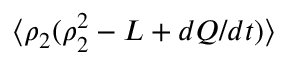Convert formula to latex. <formula><loc_0><loc_0><loc_500><loc_500>\langle \rho _ { 2 } ( \rho _ { 2 } ^ { 2 } - L + d Q / d t ) \rangle</formula> 